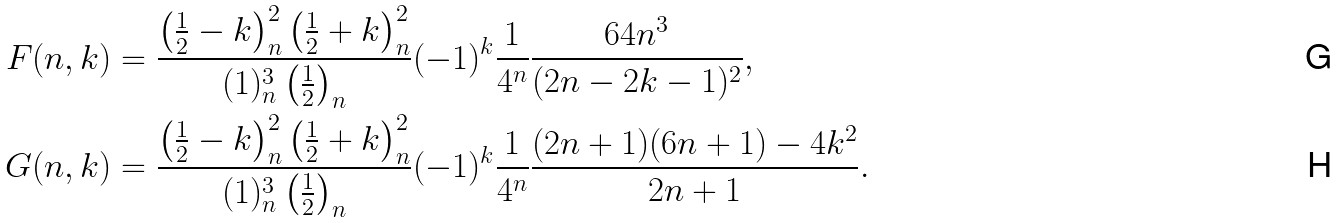Convert formula to latex. <formula><loc_0><loc_0><loc_500><loc_500>F ( n , k ) & = \frac { \left ( \frac { 1 } { 2 } - k \right ) _ { n } ^ { 2 } \left ( \frac { 1 } { 2 } + k \right ) _ { n } ^ { 2 } } { ( 1 ) _ { n } ^ { 3 } \left ( \frac { 1 } { 2 } \right ) _ { n } } ( - 1 ) ^ { k } \frac { 1 } { 4 ^ { n } } \frac { 6 4 n ^ { 3 } } { ( 2 n - 2 k - 1 ) ^ { 2 } } , \\ G ( n , k ) & = \frac { \left ( \frac { 1 } { 2 } - k \right ) _ { n } ^ { 2 } \left ( \frac { 1 } { 2 } + k \right ) _ { n } ^ { 2 } } { ( 1 ) _ { n } ^ { 3 } \left ( \frac { 1 } { 2 } \right ) _ { n } } ( - 1 ) ^ { k } \frac { 1 } { 4 ^ { n } } \frac { ( 2 n + 1 ) ( 6 n + 1 ) - 4 k ^ { 2 } } { 2 n + 1 } .</formula> 